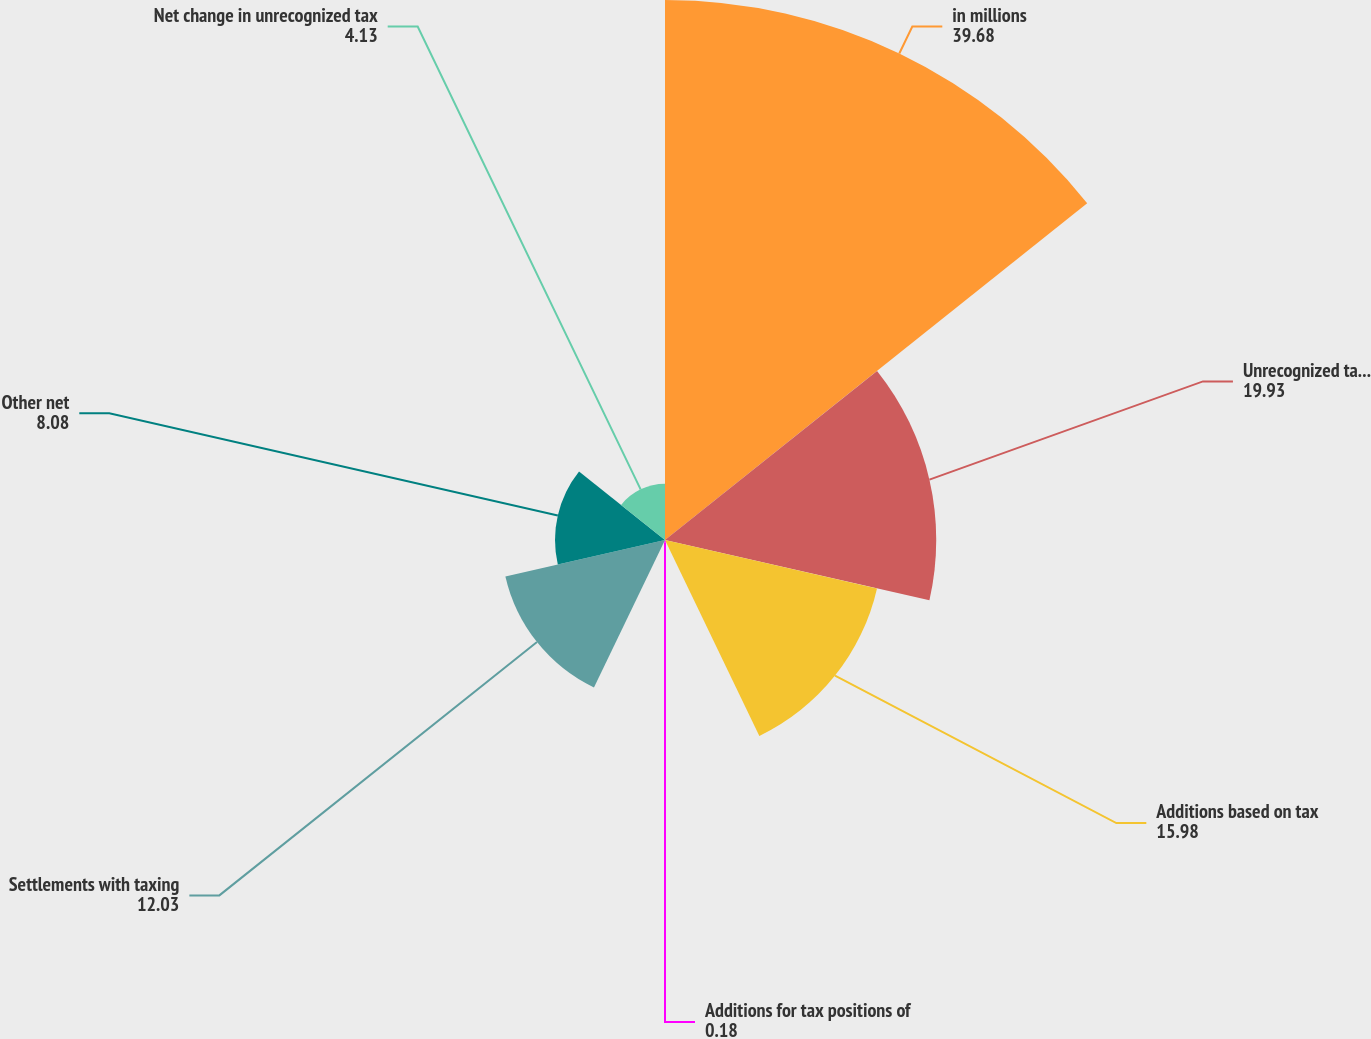Convert chart to OTSL. <chart><loc_0><loc_0><loc_500><loc_500><pie_chart><fcel>in millions<fcel>Unrecognized tax benefits at<fcel>Additions based on tax<fcel>Additions for tax positions of<fcel>Settlements with taxing<fcel>Other net<fcel>Net change in unrecognized tax<nl><fcel>39.68%<fcel>19.93%<fcel>15.98%<fcel>0.18%<fcel>12.03%<fcel>8.08%<fcel>4.13%<nl></chart> 